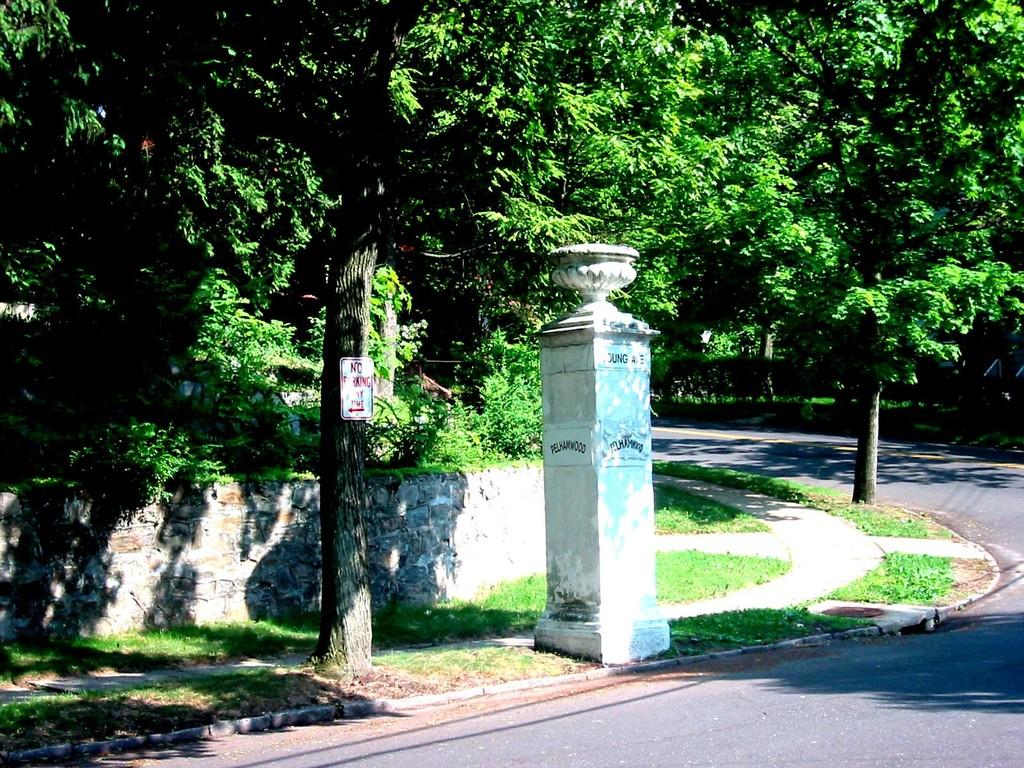What is located at the bottom of the image? There is a road at the bottom of the image. What type of natural elements can be seen in the image? Trees are visible in the image. What structure is in the center of the image? There is a pillar in the center of the image. How many trees are moving in the image? There are no trees moving in the image; the trees are stationary. What type of tree is present in the image? The provided facts do not specify the type of tree, only that trees are visible in the image. 